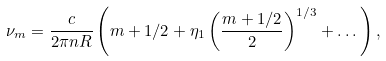Convert formula to latex. <formula><loc_0><loc_0><loc_500><loc_500>\nu _ { m } = \frac { c } { 2 \pi n R } \left ( m + 1 / 2 + \eta _ { 1 } \left ( \frac { m + 1 / 2 } { 2 } \right ) ^ { 1 / 3 } + \dots \right ) ,</formula> 